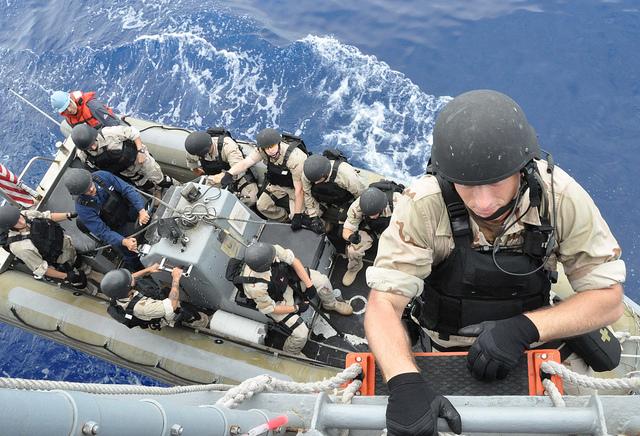Are the men having a tea party?
Keep it brief. No. Are these army men?
Concise answer only. Yes. How many men are there?
Short answer required. 10. 